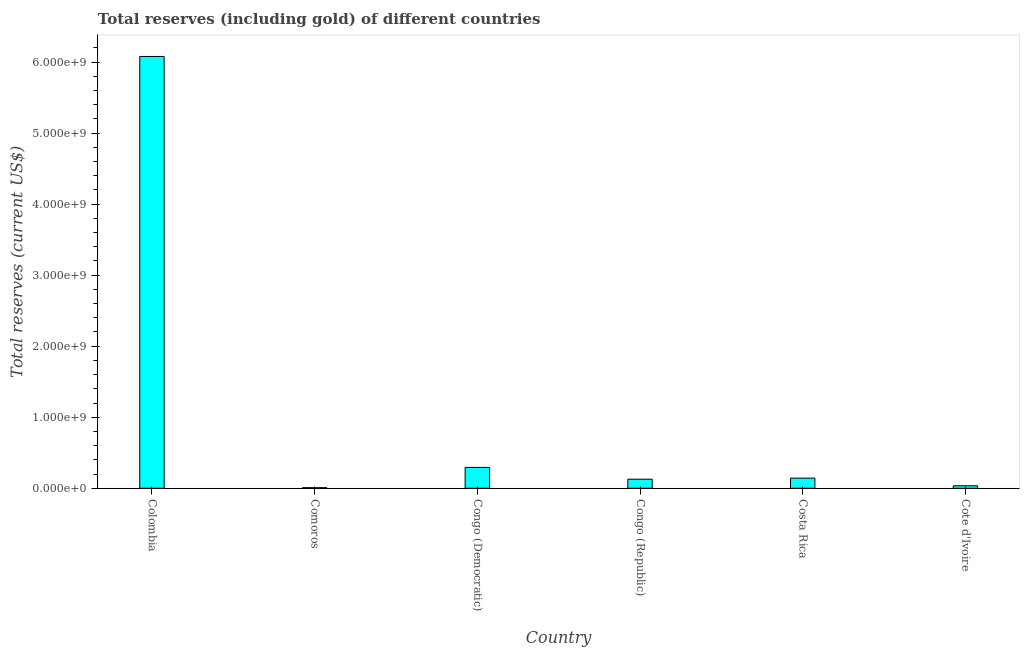What is the title of the graph?
Offer a very short reply. Total reserves (including gold) of different countries. What is the label or title of the X-axis?
Give a very brief answer. Country. What is the label or title of the Y-axis?
Give a very brief answer. Total reserves (current US$). What is the total reserves (including gold) in Colombia?
Your answer should be very brief. 6.08e+09. Across all countries, what is the maximum total reserves (including gold)?
Ensure brevity in your answer.  6.08e+09. Across all countries, what is the minimum total reserves (including gold)?
Give a very brief answer. 8.39e+06. In which country was the total reserves (including gold) minimum?
Offer a very short reply. Comoros. What is the sum of the total reserves (including gold)?
Your answer should be compact. 6.69e+09. What is the difference between the total reserves (including gold) in Colombia and Congo (Democratic)?
Make the answer very short. 5.78e+09. What is the average total reserves (including gold) per country?
Ensure brevity in your answer.  1.11e+09. What is the median total reserves (including gold)?
Your answer should be compact. 1.35e+08. What is the ratio of the total reserves (including gold) in Colombia to that in Congo (Democratic)?
Your answer should be compact. 20.68. What is the difference between the highest and the second highest total reserves (including gold)?
Provide a short and direct response. 5.78e+09. What is the difference between the highest and the lowest total reserves (including gold)?
Keep it short and to the point. 6.07e+09. In how many countries, is the total reserves (including gold) greater than the average total reserves (including gold) taken over all countries?
Offer a very short reply. 1. How many bars are there?
Give a very brief answer. 6. How many countries are there in the graph?
Provide a short and direct response. 6. What is the difference between two consecutive major ticks on the Y-axis?
Your answer should be very brief. 1.00e+09. What is the Total reserves (current US$) in Colombia?
Your response must be concise. 6.08e+09. What is the Total reserves (current US$) of Comoros?
Offer a terse response. 8.39e+06. What is the Total reserves (current US$) of Congo (Democratic)?
Your answer should be very brief. 2.94e+08. What is the Total reserves (current US$) of Congo (Republic)?
Keep it short and to the point. 1.28e+08. What is the Total reserves (current US$) of Costa Rica?
Provide a short and direct response. 1.43e+08. What is the Total reserves (current US$) in Cote d'Ivoire?
Offer a very short reply. 3.55e+07. What is the difference between the Total reserves (current US$) in Colombia and Comoros?
Give a very brief answer. 6.07e+09. What is the difference between the Total reserves (current US$) in Colombia and Congo (Democratic)?
Your response must be concise. 5.78e+09. What is the difference between the Total reserves (current US$) in Colombia and Congo (Republic)?
Keep it short and to the point. 5.95e+09. What is the difference between the Total reserves (current US$) in Colombia and Costa Rica?
Ensure brevity in your answer.  5.94e+09. What is the difference between the Total reserves (current US$) in Colombia and Cote d'Ivoire?
Ensure brevity in your answer.  6.04e+09. What is the difference between the Total reserves (current US$) in Comoros and Congo (Democratic)?
Provide a short and direct response. -2.85e+08. What is the difference between the Total reserves (current US$) in Comoros and Congo (Republic)?
Ensure brevity in your answer.  -1.20e+08. What is the difference between the Total reserves (current US$) in Comoros and Costa Rica?
Give a very brief answer. -1.35e+08. What is the difference between the Total reserves (current US$) in Comoros and Cote d'Ivoire?
Give a very brief answer. -2.71e+07. What is the difference between the Total reserves (current US$) in Congo (Democratic) and Congo (Republic)?
Offer a terse response. 1.66e+08. What is the difference between the Total reserves (current US$) in Congo (Democratic) and Costa Rica?
Give a very brief answer. 1.51e+08. What is the difference between the Total reserves (current US$) in Congo (Democratic) and Cote d'Ivoire?
Ensure brevity in your answer.  2.58e+08. What is the difference between the Total reserves (current US$) in Congo (Republic) and Costa Rica?
Provide a short and direct response. -1.50e+07. What is the difference between the Total reserves (current US$) in Congo (Republic) and Cote d'Ivoire?
Your answer should be very brief. 9.24e+07. What is the difference between the Total reserves (current US$) in Costa Rica and Cote d'Ivoire?
Your response must be concise. 1.07e+08. What is the ratio of the Total reserves (current US$) in Colombia to that in Comoros?
Your response must be concise. 724.35. What is the ratio of the Total reserves (current US$) in Colombia to that in Congo (Democratic)?
Your response must be concise. 20.68. What is the ratio of the Total reserves (current US$) in Colombia to that in Congo (Republic)?
Give a very brief answer. 47.52. What is the ratio of the Total reserves (current US$) in Colombia to that in Costa Rica?
Offer a very short reply. 42.53. What is the ratio of the Total reserves (current US$) in Colombia to that in Cote d'Ivoire?
Provide a short and direct response. 171.05. What is the ratio of the Total reserves (current US$) in Comoros to that in Congo (Democratic)?
Keep it short and to the point. 0.03. What is the ratio of the Total reserves (current US$) in Comoros to that in Congo (Republic)?
Ensure brevity in your answer.  0.07. What is the ratio of the Total reserves (current US$) in Comoros to that in Costa Rica?
Keep it short and to the point. 0.06. What is the ratio of the Total reserves (current US$) in Comoros to that in Cote d'Ivoire?
Make the answer very short. 0.24. What is the ratio of the Total reserves (current US$) in Congo (Democratic) to that in Congo (Republic)?
Provide a succinct answer. 2.3. What is the ratio of the Total reserves (current US$) in Congo (Democratic) to that in Costa Rica?
Offer a very short reply. 2.06. What is the ratio of the Total reserves (current US$) in Congo (Democratic) to that in Cote d'Ivoire?
Offer a terse response. 8.27. What is the ratio of the Total reserves (current US$) in Congo (Republic) to that in Costa Rica?
Ensure brevity in your answer.  0.9. What is the ratio of the Total reserves (current US$) in Congo (Republic) to that in Cote d'Ivoire?
Your answer should be very brief. 3.6. What is the ratio of the Total reserves (current US$) in Costa Rica to that in Cote d'Ivoire?
Provide a succinct answer. 4.02. 